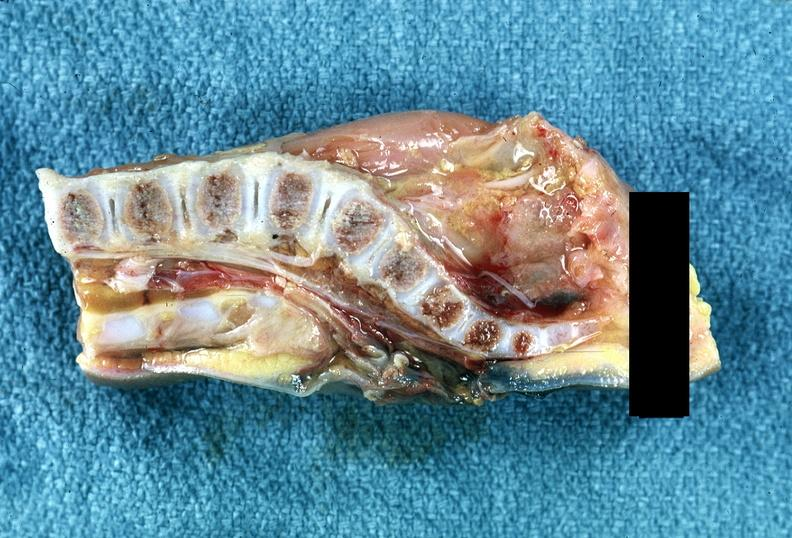does this image show neural tube defect?
Answer the question using a single word or phrase. Yes 